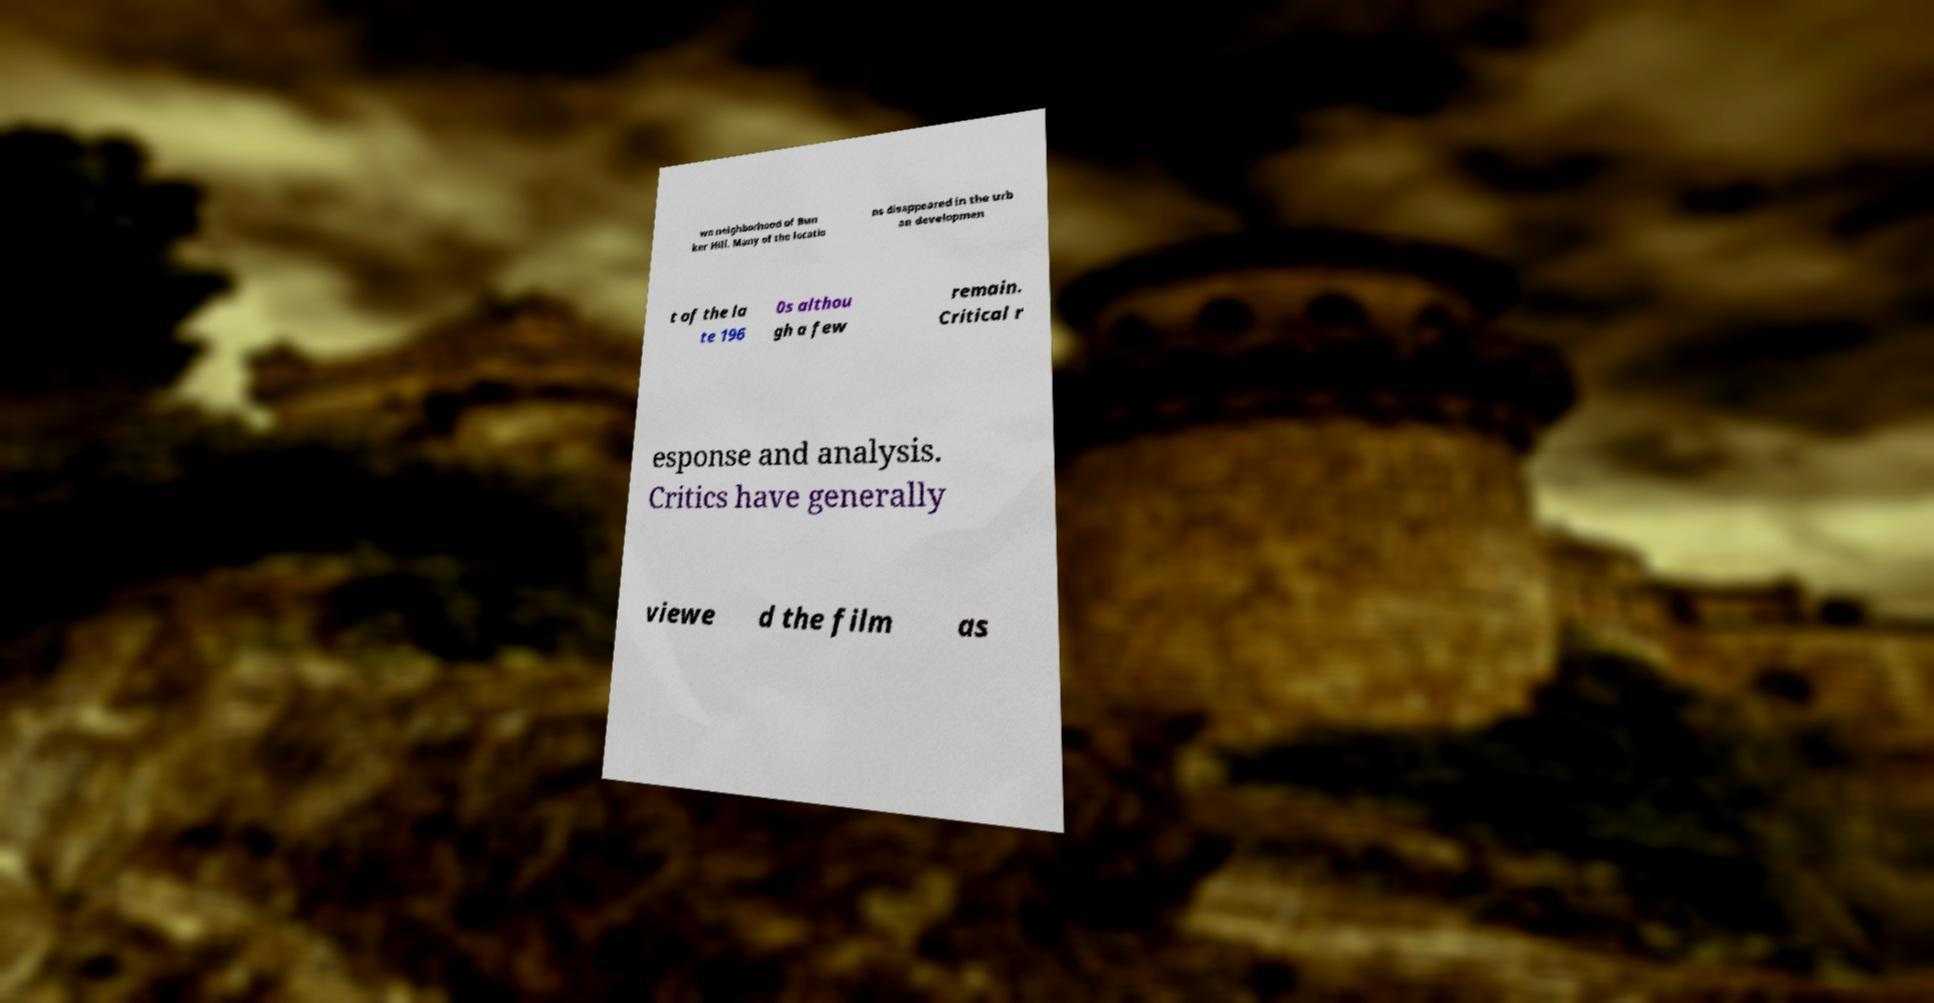For documentation purposes, I need the text within this image transcribed. Could you provide that? wn neighborhood of Bun ker Hill. Many of the locatio ns disappeared in the urb an developmen t of the la te 196 0s althou gh a few remain. Critical r esponse and analysis. Critics have generally viewe d the film as 